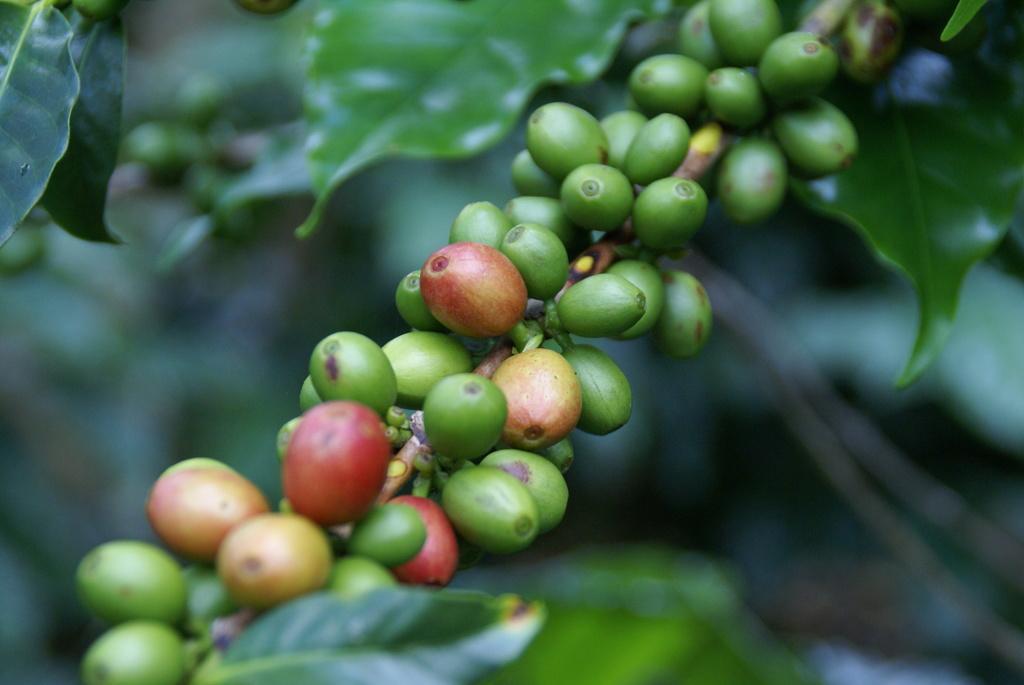Can you describe this image briefly? Here we can see coffee beans and green leaves. In the background it is blur. 